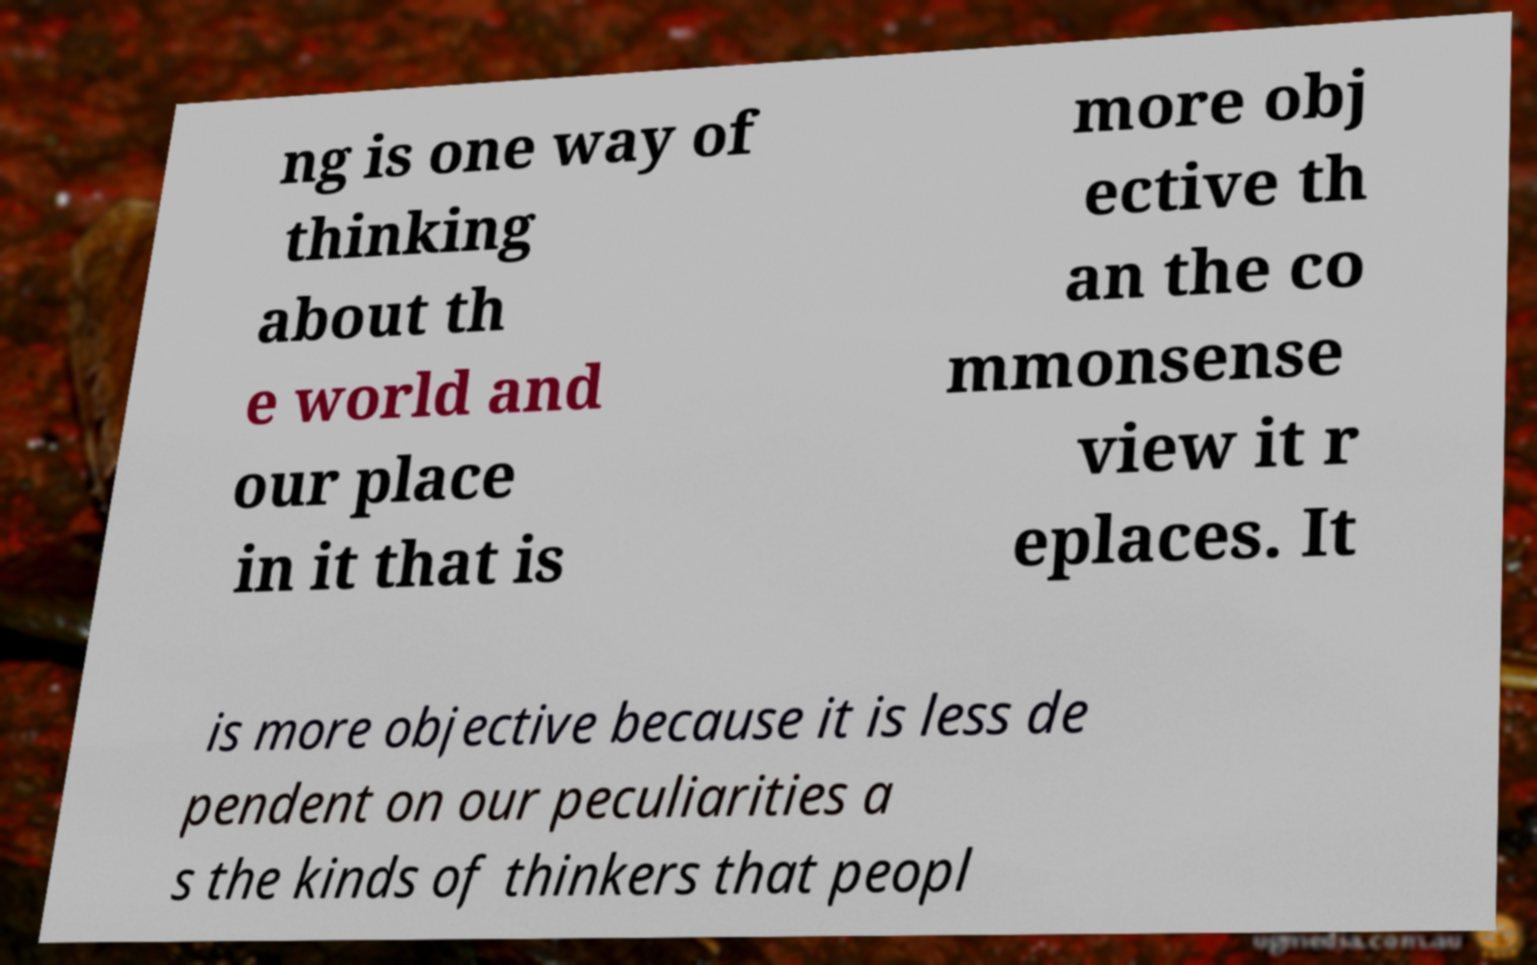There's text embedded in this image that I need extracted. Can you transcribe it verbatim? ng is one way of thinking about th e world and our place in it that is more obj ective th an the co mmonsense view it r eplaces. It is more objective because it is less de pendent on our peculiarities a s the kinds of thinkers that peopl 